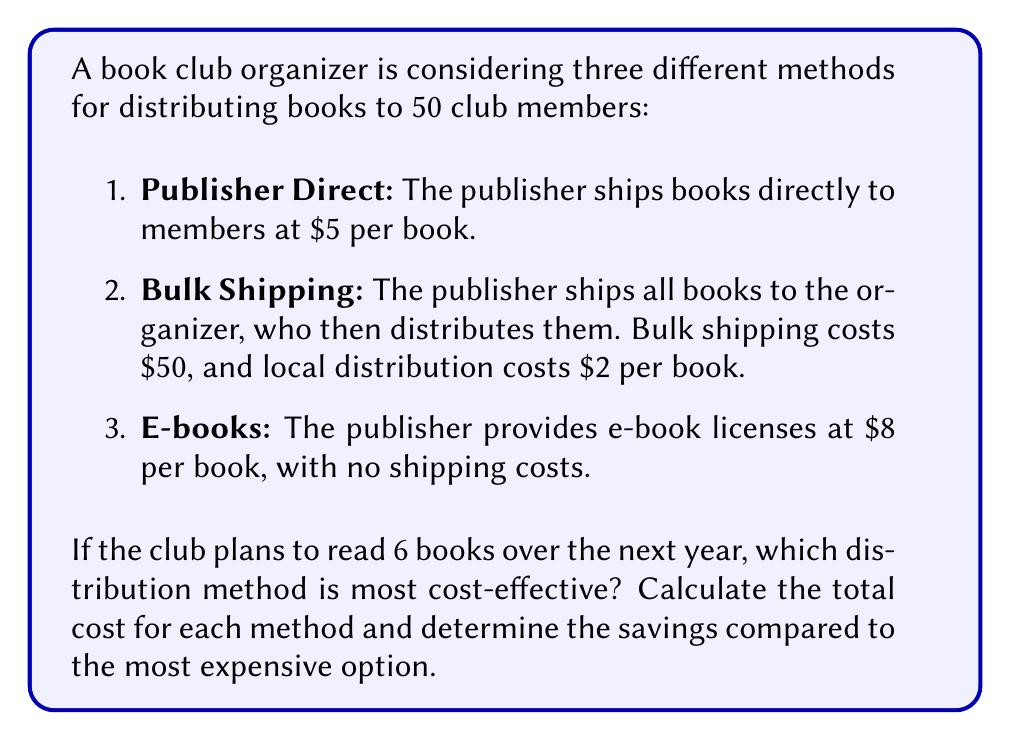Can you solve this math problem? Let's calculate the cost for each method:

1. Publisher Direct:
   Cost = Number of members × Number of books × Cost per book
   $$C_1 = 50 \times 6 \times $5 = $1500$$

2. Bulk Shipping:
   Cost = Bulk shipping cost + (Number of members × Number of books × Local distribution cost)
   $$C_2 = $50 + (50 \times 6 \times $2) = $650$$

3. E-books:
   Cost = Number of members × Number of books × Cost per e-book
   $$C_3 = 50 \times 6 \times $8 = $2400$$

To determine the most cost-effective method, we compare the total costs:
$$C_2 < C_1 < C_3$$

Bulk Shipping (Method 2) is the most cost-effective.

To calculate savings compared to the most expensive option (E-books):

Savings for Bulk Shipping:
$$S_2 = C_3 - C_2 = $2400 - $650 = $1750$$

Savings for Publisher Direct:
$$S_1 = C_3 - C_1 = $2400 - $1500 = $900$$
Answer: The most cost-effective method is Bulk Shipping, with a total cost of $650. This method saves $1750 compared to the most expensive option (E-books). 